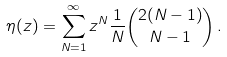Convert formula to latex. <formula><loc_0><loc_0><loc_500><loc_500>\eta ( z ) = \sum _ { N = 1 } ^ { \infty } z ^ { N } \frac { 1 } { N } { 2 ( N - 1 ) \choose N - 1 } \, .</formula> 